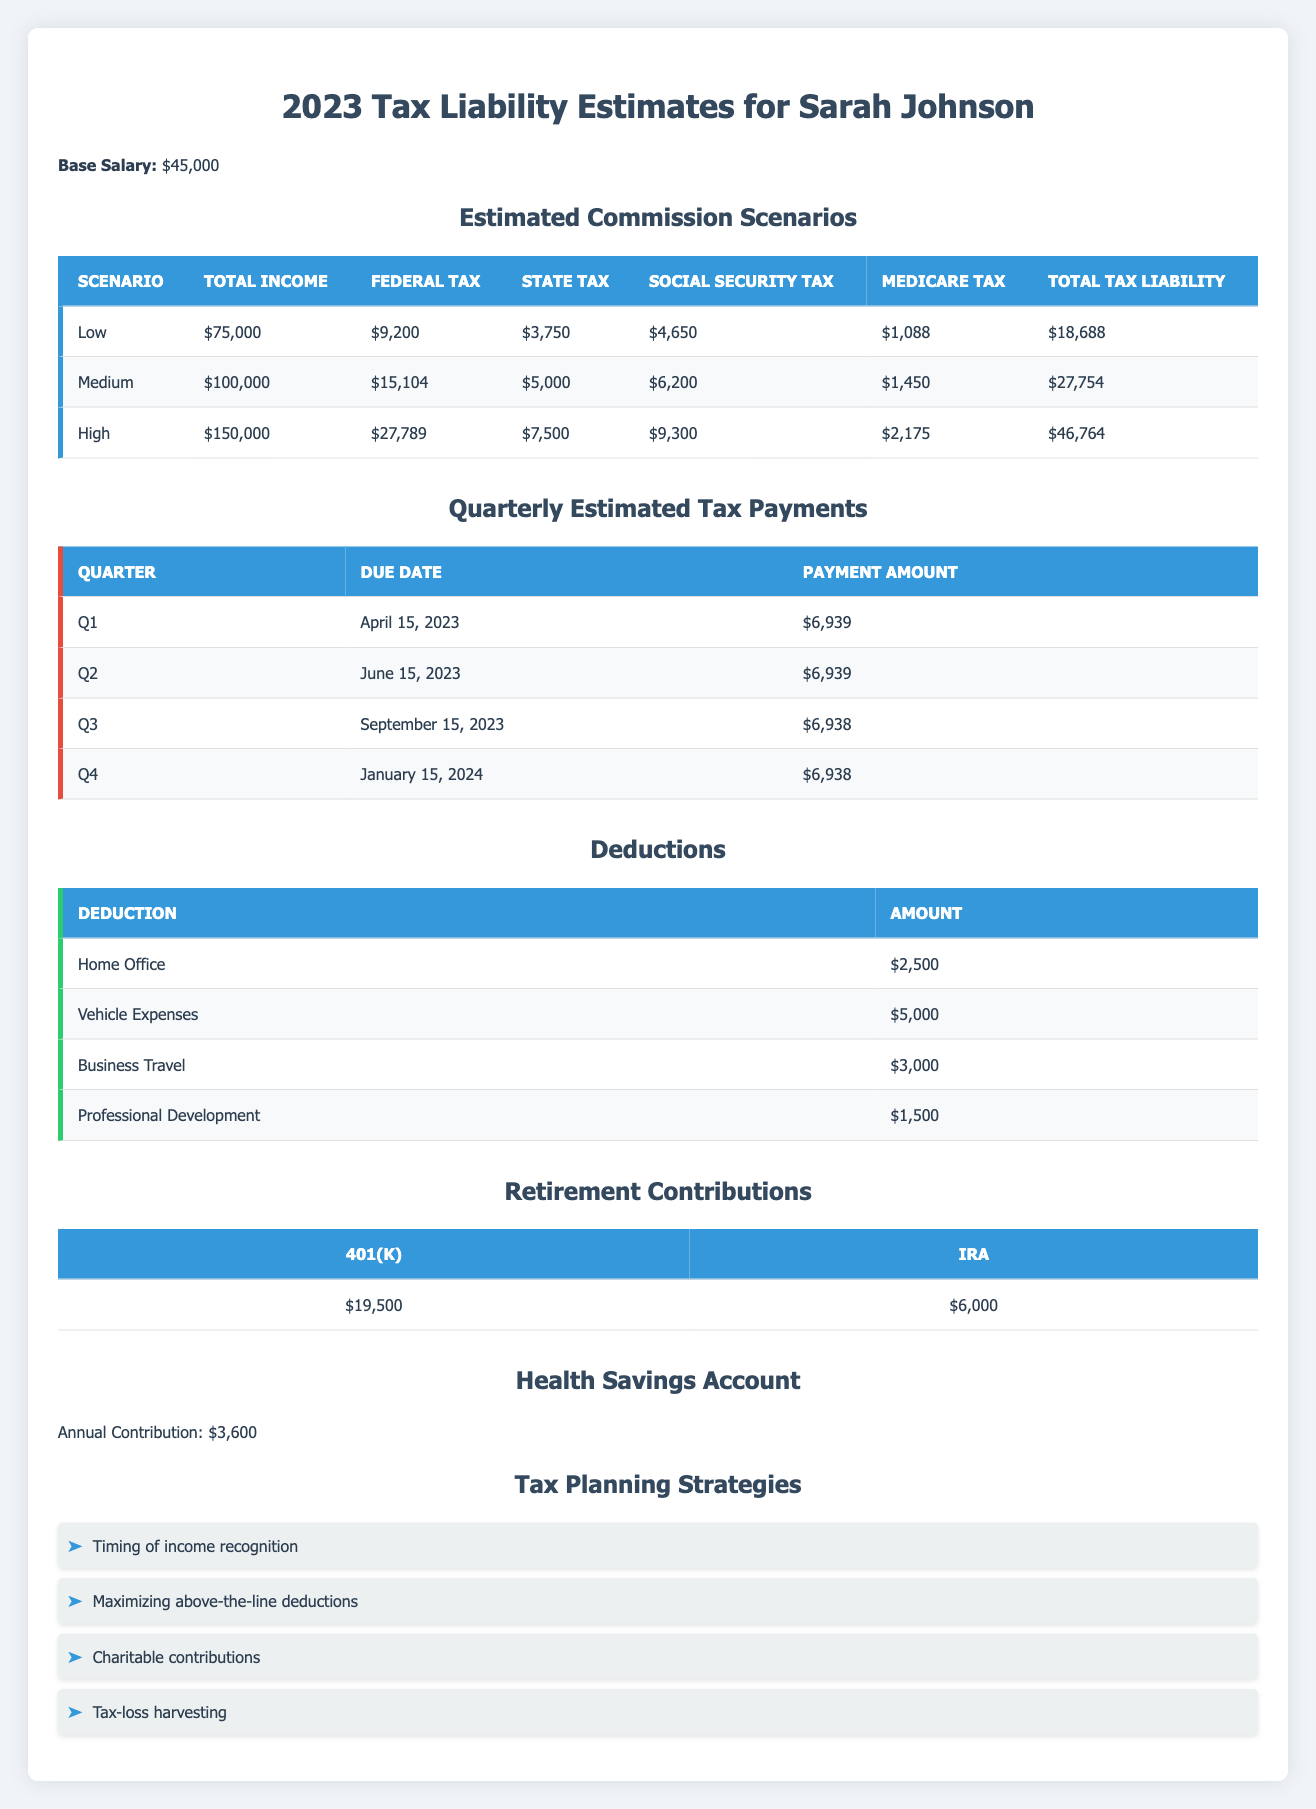What is Sarah's total estimated tax liability in the medium income scenario? In the medium income scenario, the total tax liability is listed as $27,754 in the table.
Answer: 27,754 What is the total amount of all deductions? To find the total amount of deductions, we add the amounts: $2,500 + $5,000 + $3,000 + $1,500 = $12,000.
Answer: 12,000 Is Sarah's federal tax liability lower in the low income scenario compared to the high income scenario? In the low income scenario, the federal tax is $9,200, while in the high income scenario it is $27,789. Since $9,200 is less than $27,789, the answer is yes.
Answer: Yes What is the difference between the total tax liability in the high scenario and the low scenario? The total tax liability in the high scenario is $46,764 and in the low scenario is $18,688. The difference is $46,764 - $18,688 = $28,076.
Answer: 28,076 What is the average quarterly estimated tax payment? The quarterly estimated tax payments are $6,939, $6,939, $6,938, and $6,938. The total is $6,939 + $6,939 + $6,938 + $6,938 = $27,754. Dividing this by 4 gives an average of $27,754 / 4 = $6,938.50, which rounds to $6,939.
Answer: 6,939 What is the total amount Sarah contributes to her retirement accounts? Sarah contributes $19,500 to her 401(k) and $6,000 to her IRA. The total contribution is $19,500 + $6,000 = $25,500.
Answer: 25,500 In which quarter does Sarah have the lowest estimated tax payment? The payments are $6,939 for Q1, $6,939 for Q2, $6,938 for Q3, and $6,938 for Q4. Comparing these amounts, Q3 and Q4 both have the lowest payment of $6,938.
Answer: Q3 and Q4 What are Sarah's total contributions to her Health Savings Account and retirement accounts combined? Sarah contributes $3,600 to her Health Savings Account and $25,500 to her retirement accounts. Therefore, the total is $3,600 + $25,500 = $29,100.
Answer: 29,100 What types of tax planning strategies does Sarah employ? The tax planning strategies listed are: Timing of income recognition, Maximizing above-the-line deductions, Charitable contributions, and Tax-loss harvesting, totaling four strategies.
Answer: Four strategies 